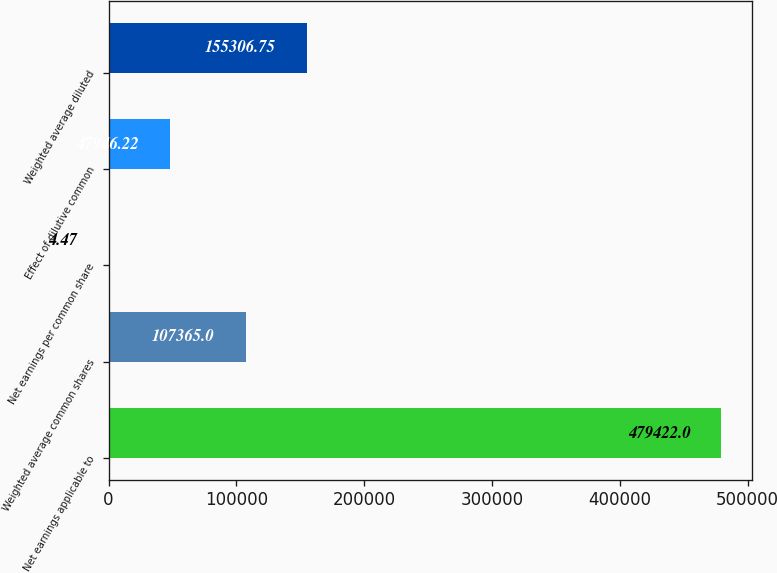Convert chart. <chart><loc_0><loc_0><loc_500><loc_500><bar_chart><fcel>Net earnings applicable to<fcel>Weighted average common shares<fcel>Net earnings per common share<fcel>Effect of dilutive common<fcel>Weighted average diluted<nl><fcel>479422<fcel>107365<fcel>4.47<fcel>47946.2<fcel>155307<nl></chart> 